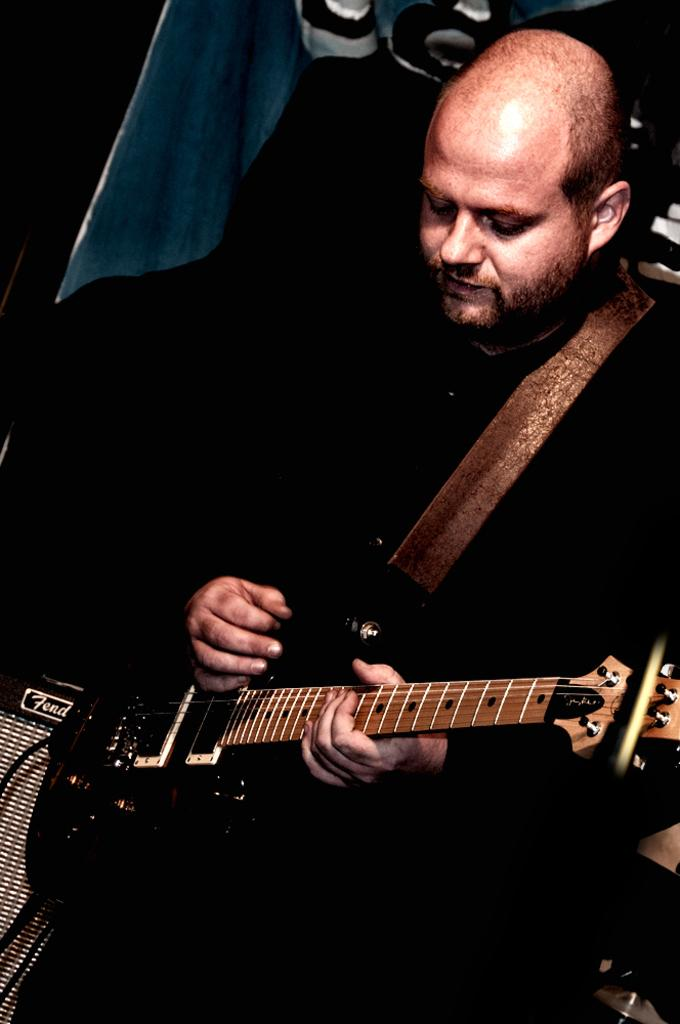What is the man in the image doing? The man is playing a guitar in the image. What is the man wearing while playing the guitar? The man is wearing a black dress in the image. How many clocks can be seen in the image? There are no clocks visible in the image. What type of stew is being prepared in the image? There is no stew or cooking activity present in the image. 